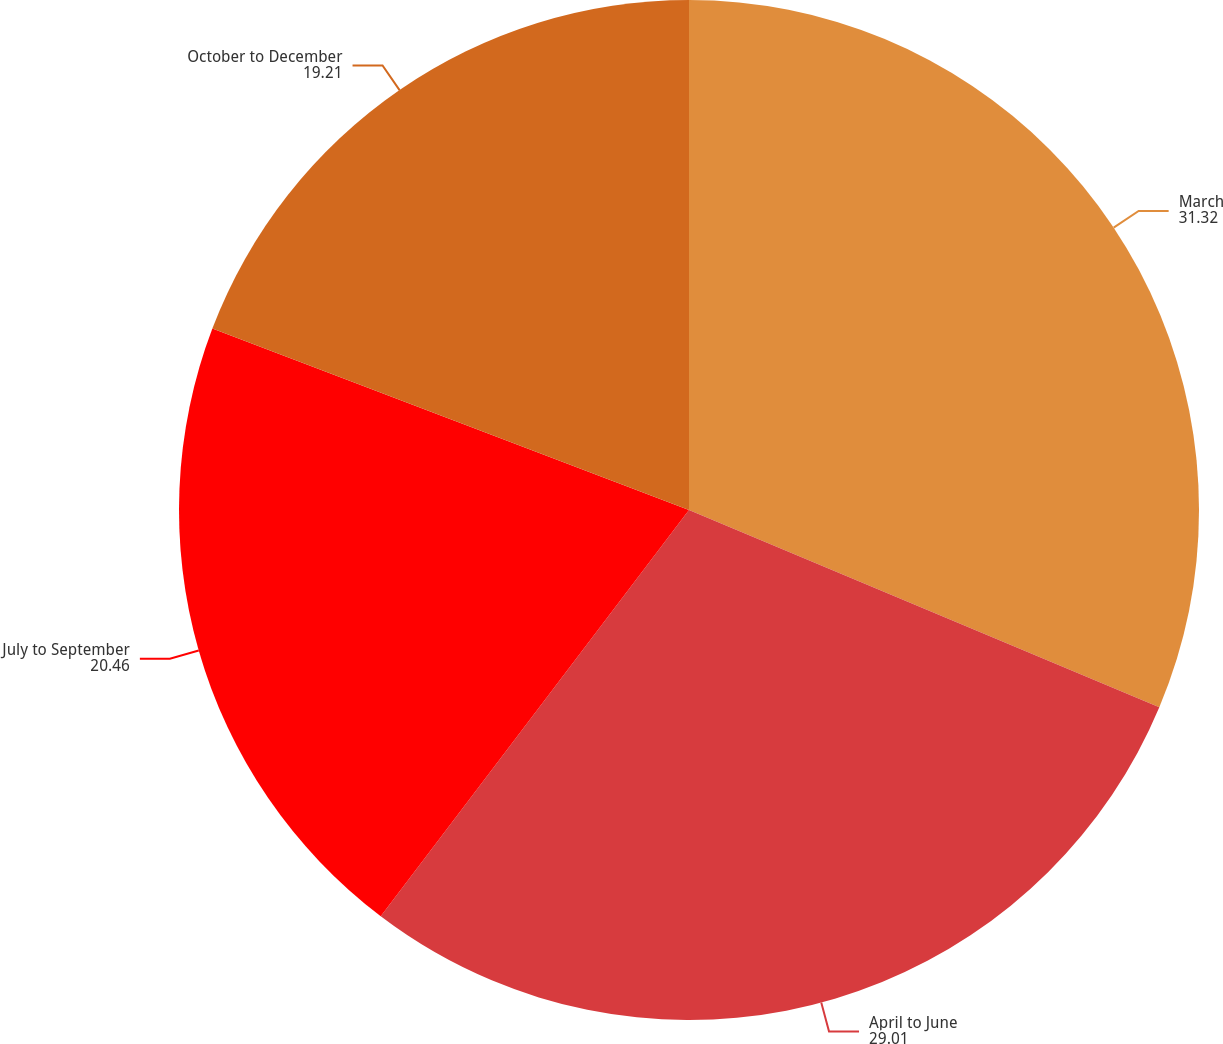Convert chart to OTSL. <chart><loc_0><loc_0><loc_500><loc_500><pie_chart><fcel>March<fcel>April to June<fcel>July to September<fcel>October to December<nl><fcel>31.32%<fcel>29.01%<fcel>20.46%<fcel>19.21%<nl></chart> 